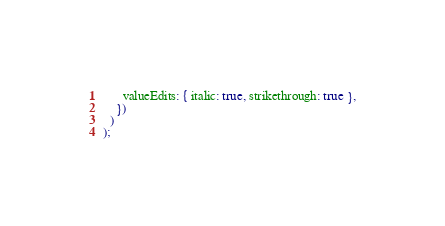<code> <loc_0><loc_0><loc_500><loc_500><_TypeScript_>      valueEdits: { italic: true, strikethrough: true },
    })
  )
);
</code> 